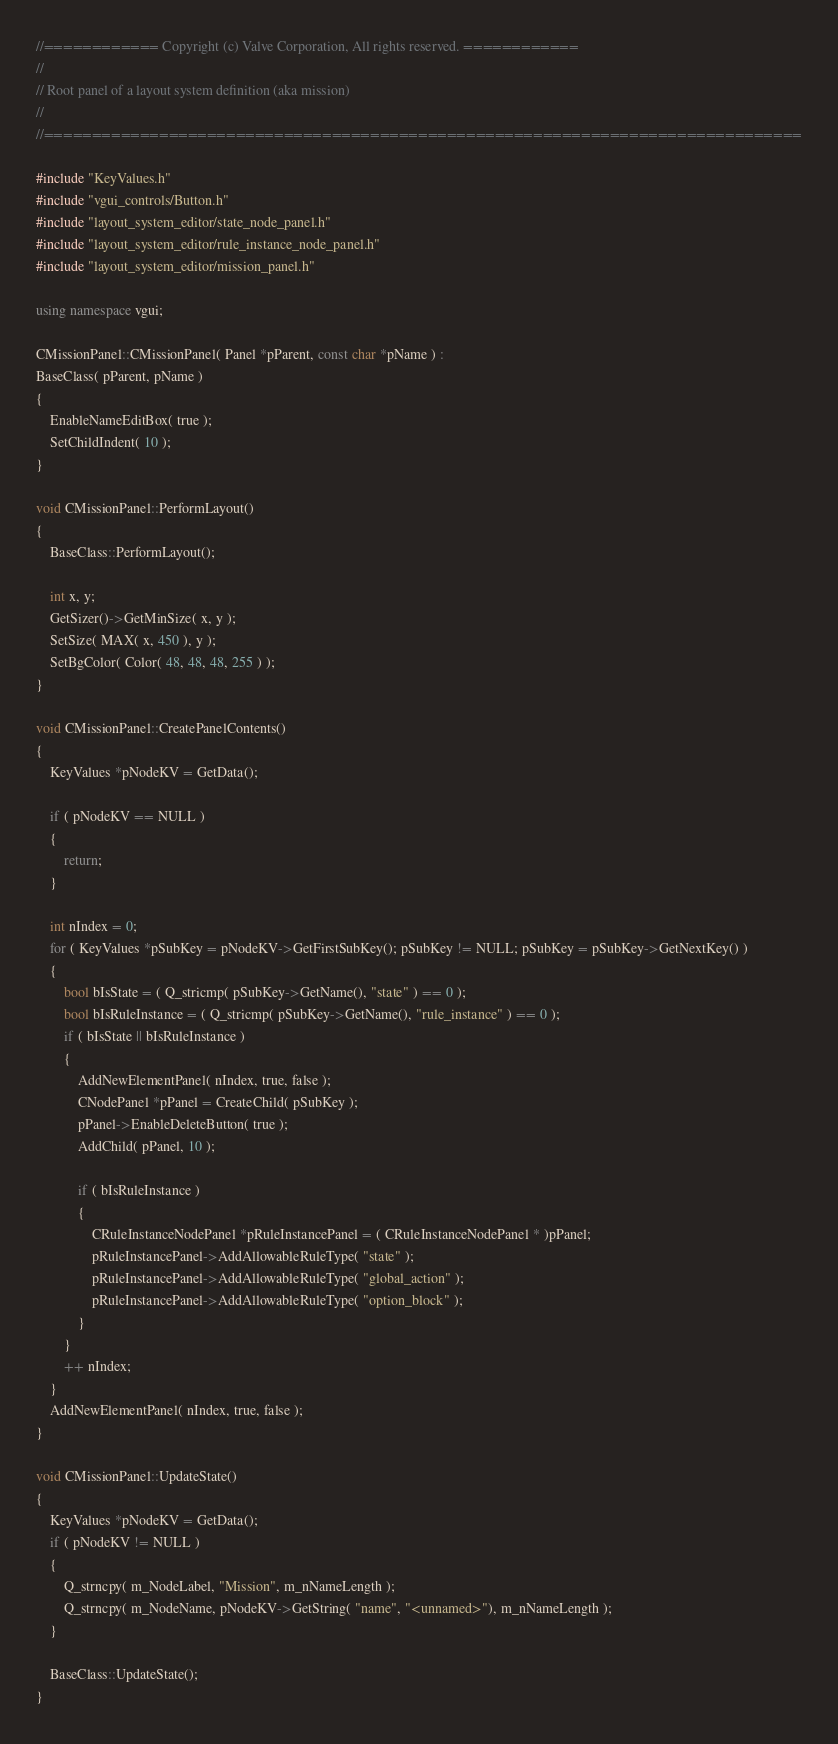<code> <loc_0><loc_0><loc_500><loc_500><_C++_>//============ Copyright (c) Valve Corporation, All rights reserved. ============
//
// Root panel of a layout system definition (aka mission)
//
//===============================================================================

#include "KeyValues.h"
#include "vgui_controls/Button.h"
#include "layout_system_editor/state_node_panel.h"
#include "layout_system_editor/rule_instance_node_panel.h"
#include "layout_system_editor/mission_panel.h"

using namespace vgui;

CMissionPanel::CMissionPanel( Panel *pParent, const char *pName ) : 
BaseClass( pParent, pName ) 
{ 
	EnableNameEditBox( true );
	SetChildIndent( 10 );
}

void CMissionPanel::PerformLayout()
{
	BaseClass::PerformLayout();
	
	int x, y;
	GetSizer()->GetMinSize( x, y );
	SetSize( MAX( x, 450 ), y );
	SetBgColor( Color( 48, 48, 48, 255 ) );
}

void CMissionPanel::CreatePanelContents()
{
	KeyValues *pNodeKV = GetData();

	if ( pNodeKV == NULL )
	{
		return;
	}

	int nIndex = 0;
	for ( KeyValues *pSubKey = pNodeKV->GetFirstSubKey(); pSubKey != NULL; pSubKey = pSubKey->GetNextKey() )
	{
		bool bIsState = ( Q_stricmp( pSubKey->GetName(), "state" ) == 0 );
		bool bIsRuleInstance = ( Q_stricmp( pSubKey->GetName(), "rule_instance" ) == 0 );
		if ( bIsState || bIsRuleInstance )
		{
			AddNewElementPanel( nIndex, true, false );
			CNodePanel *pPanel = CreateChild( pSubKey );
			pPanel->EnableDeleteButton( true );
			AddChild( pPanel, 10 );

			if ( bIsRuleInstance )
			{
				CRuleInstanceNodePanel *pRuleInstancePanel = ( CRuleInstanceNodePanel * )pPanel;
				pRuleInstancePanel->AddAllowableRuleType( "state" );
				pRuleInstancePanel->AddAllowableRuleType( "global_action" );
				pRuleInstancePanel->AddAllowableRuleType( "option_block" );
			}
		}
		++ nIndex;
	}
	AddNewElementPanel( nIndex, true, false );
}

void CMissionPanel::UpdateState()
{
	KeyValues *pNodeKV = GetData();
	if ( pNodeKV != NULL )
	{
		Q_strncpy( m_NodeLabel, "Mission", m_nNameLength );
		Q_strncpy( m_NodeName, pNodeKV->GetString( "name", "<unnamed>"), m_nNameLength );
	}

	BaseClass::UpdateState();
}
</code> 